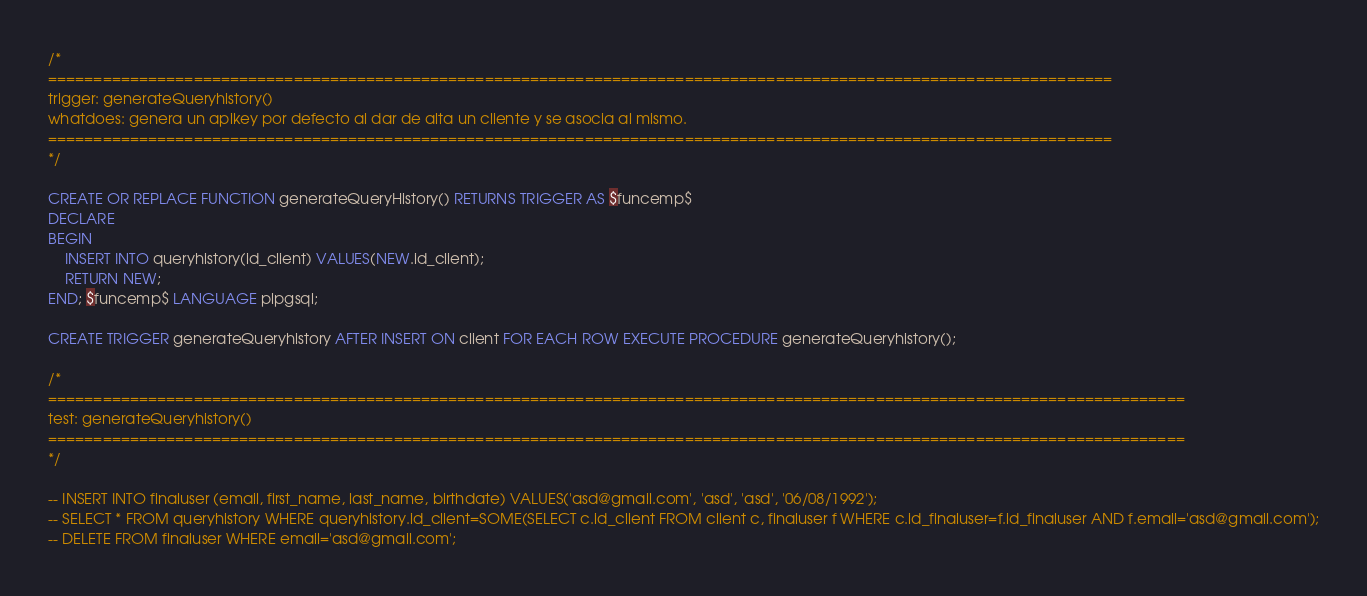Convert code to text. <code><loc_0><loc_0><loc_500><loc_500><_SQL_>/*
=====================================================================================================================
trigger: generateQueryhistory()
whatdoes: genera un apikey por defecto al dar de alta un cliente y se asocia al mismo.
=====================================================================================================================
*/

CREATE OR REPLACE FUNCTION generateQueryHistory() RETURNS TRIGGER AS $funcemp$
DECLARE
BEGIN	
	INSERT INTO queryhistory(id_client) VALUES(NEW.id_client);
	RETURN NEW;
END; $funcemp$ LANGUAGE plpgsql;

CREATE TRIGGER generateQueryhistory AFTER INSERT ON client FOR EACH ROW EXECUTE PROCEDURE generateQueryhistory();

/*
=============================================================================================================================
test: generateQueryhistory()
=============================================================================================================================
*/

-- INSERT INTO finaluser (email, first_name, last_name, birthdate) VALUES('asd@gmail.com', 'asd', 'asd', '06/08/1992');
-- SELECT * FROM queryhistory WHERE queryhistory.id_client=SOME(SELECT c.id_client FROM client c, finaluser f WHERE c.id_finaluser=f.id_finaluser AND f.email='asd@gmail.com');
-- DELETE FROM finaluser WHERE email='asd@gmail.com';</code> 